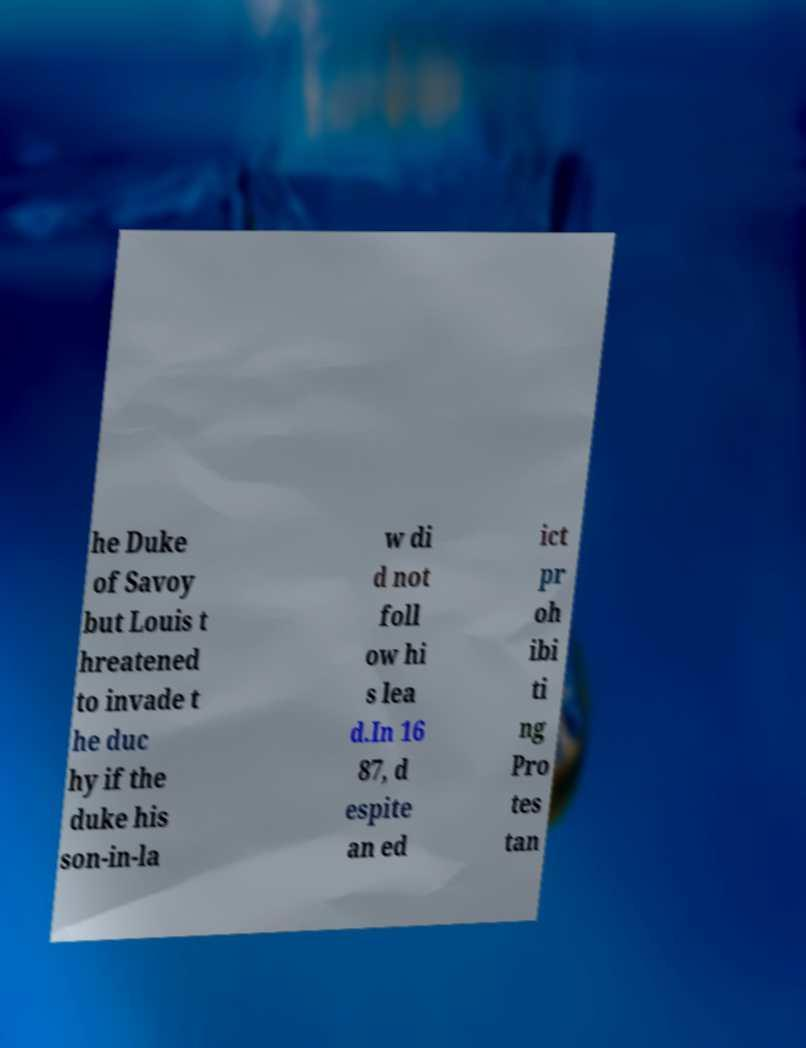I need the written content from this picture converted into text. Can you do that? he Duke of Savoy but Louis t hreatened to invade t he duc hy if the duke his son-in-la w di d not foll ow hi s lea d.In 16 87, d espite an ed ict pr oh ibi ti ng Pro tes tan 